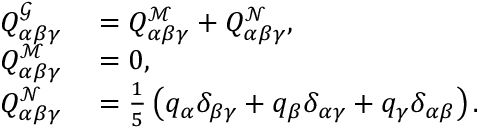<formula> <loc_0><loc_0><loc_500><loc_500>\begin{array} { r l } { Q _ { \alpha \beta \gamma } ^ { \mathcal { G } } } & = Q _ { \alpha \beta \gamma } ^ { \mathcal { M } } + Q _ { \alpha \beta \gamma } ^ { \mathcal { N } } , } \\ { Q _ { \alpha \beta \gamma } ^ { \mathcal { M } } } & = 0 , } \\ { Q _ { \alpha \beta \gamma } ^ { \mathcal { N } } } & = \frac { 1 } { 5 } \left ( q _ { \alpha } \delta _ { \beta \gamma } + q _ { \beta } \delta _ { \alpha \gamma } + q _ { \gamma } \delta _ { \alpha \beta } \right ) . } \end{array}</formula> 